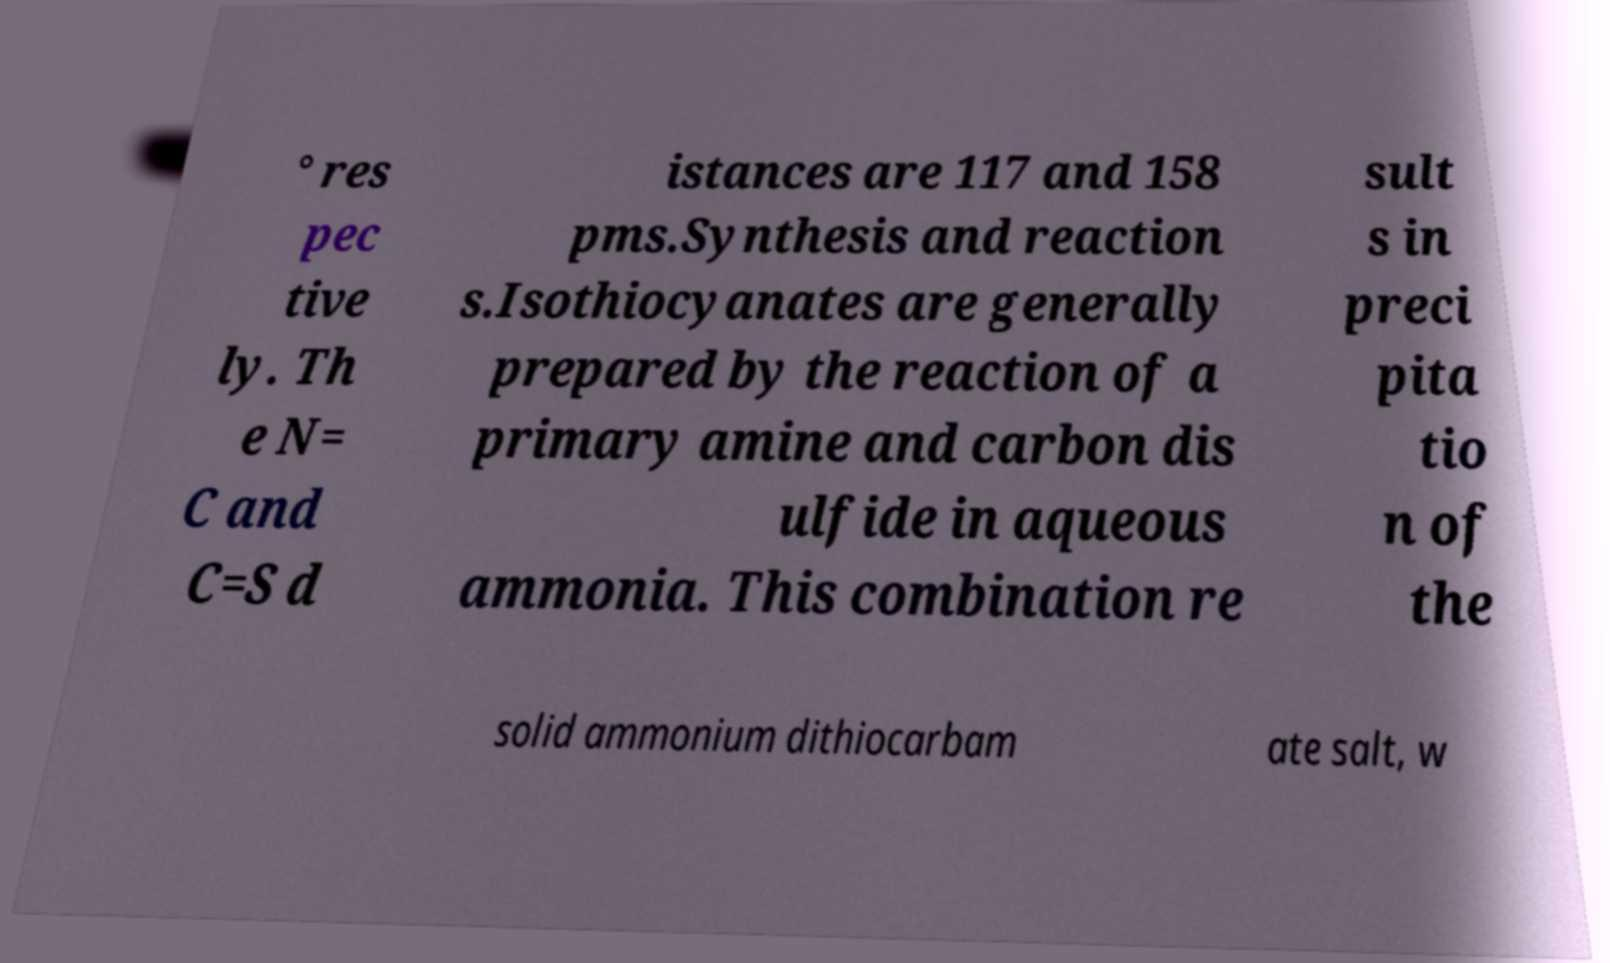Could you assist in decoding the text presented in this image and type it out clearly? ° res pec tive ly. Th e N= C and C=S d istances are 117 and 158 pms.Synthesis and reaction s.Isothiocyanates are generally prepared by the reaction of a primary amine and carbon dis ulfide in aqueous ammonia. This combination re sult s in preci pita tio n of the solid ammonium dithiocarbam ate salt, w 